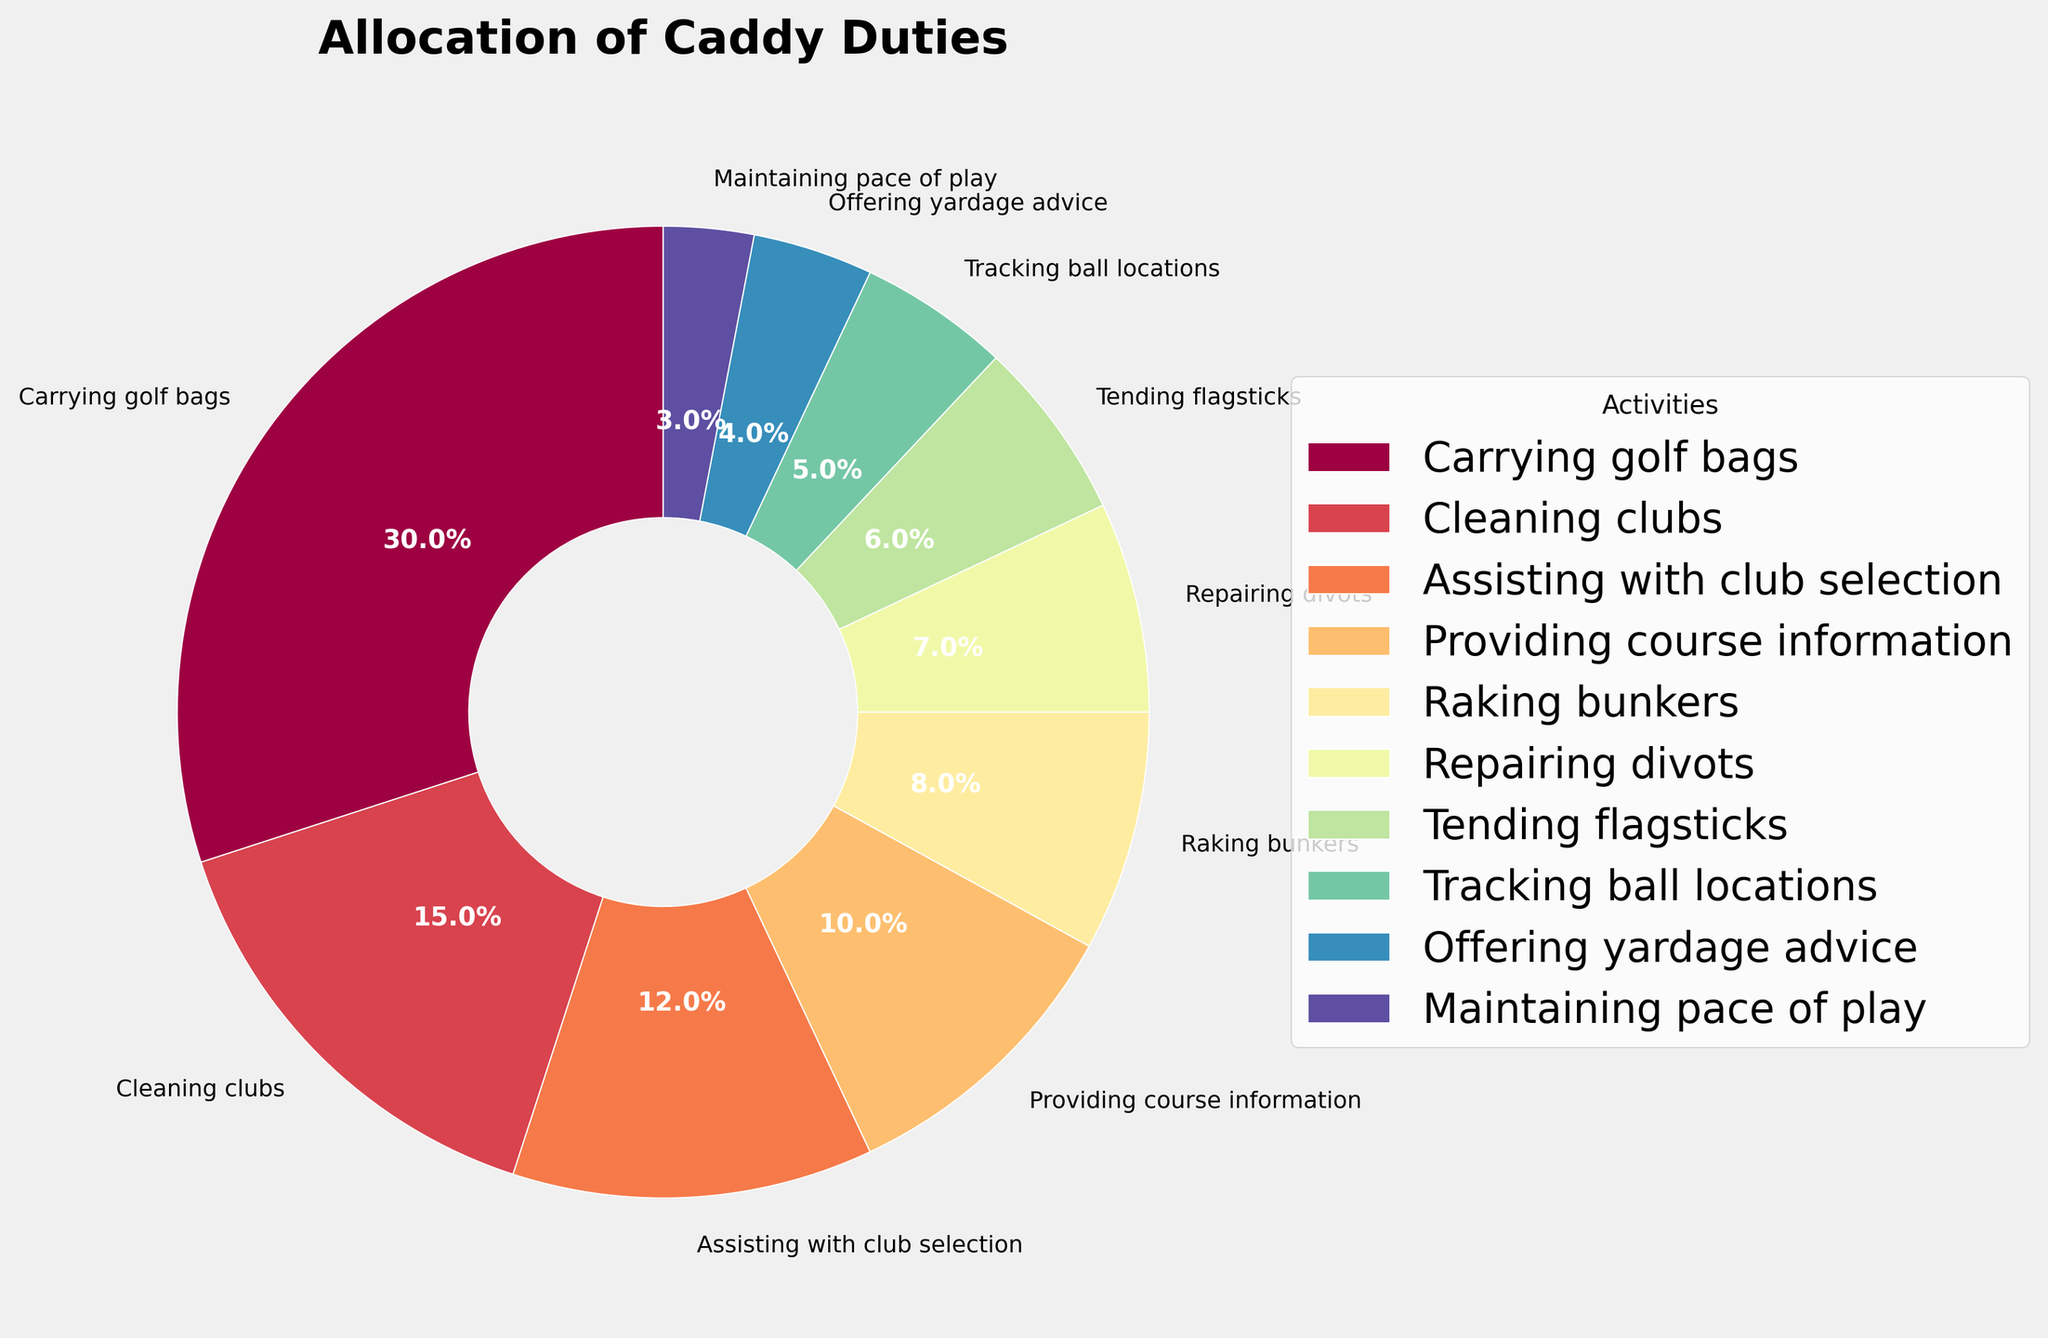What's the most time-consuming activity for a caddy? The pie chart shows that 'Carrying golf bags' has the largest slice, which means it's the most time-consuming activity for a caddy.
Answer: Carrying golf bags Which two activities take up almost the same amount of time? By observing the pie chart, 'Providing course information' and 'Raking bunkers' have similar sized slices.
Answer: Providing course information and Raking bunkers How much total time is spent on 'Repairing divots', 'Tending flagsticks', and 'Tracking ball locations'? By adding the percentages of 'Repairing divots' (7%), 'Tending flagsticks' (6%), and 'Tracking ball locations' (5%), we get 7 + 6 + 5 = 18%.
Answer: 18% How much more time is spent on 'Cleaning clubs' compared to 'Offering yardage advice'? 'Cleaning clubs' takes 15% of the time, while 'Offering yardage advice' takes 4%. The difference is 15 - 4 = 11%.
Answer: 11% Is more time spent on 'Assisting with club selection' or 'Maintaining pace of play'? The pie chart indicates that 'Assisting with club selection' takes 12% of the time, while 'Maintaining pace of play' takes 3%. Therefore, more time is spent on 'Assisting with club selection'.
Answer: Assisting with club selection What percentage of time is spent on the three least time-consuming activities? The three least time-consuming activities are 'Tracking ball locations' (5%), 'Offering yardage advice' (4%), and 'Maintaining pace of play' (3%). Summing these up gives 5 + 4 + 3 = 12%.
Answer: 12% Which activities occupy less than 10% of the time each? The pie chart segments for 'Raking bunkers' (8%), 'Repairing divots' (7%), 'Tending flagsticks' (6%), 'Tracking ball locations' (5%), 'Offering yardage advice' (4%), and 'Maintaining pace of play' (3%) are all under 10%.
Answer: Raking bunkers, Repairing divots, Tending flagsticks, Tracking ball locations, Offering yardage advice, Maintaining pace of play If you were to visually compare, which segment appears the smallest? Observing the pie chart, 'Maintaining pace of play' has the smallest slice, meaning it takes up the least time.
Answer: Maintaining pace of play Which two activities together make up the same percentage as 'Carrying golf bags'? 'Carrying golf bags' takes 30% of the time. 'Cleaning clubs' (15%) and 'Assisting with club selection' (12%) together make 15 + 12 = 27%, which is closest to 30%.
Answer: Cleaning clubs and Assisting with club selection What total percentage of time is spent on 'Carrying golf bags' and 'Cleaning clubs'? The percentages for 'Carrying golf bags' and 'Cleaning clubs' are 30% and 15%, respectively. Adding these gives 30 + 15 = 45%.
Answer: 45% 